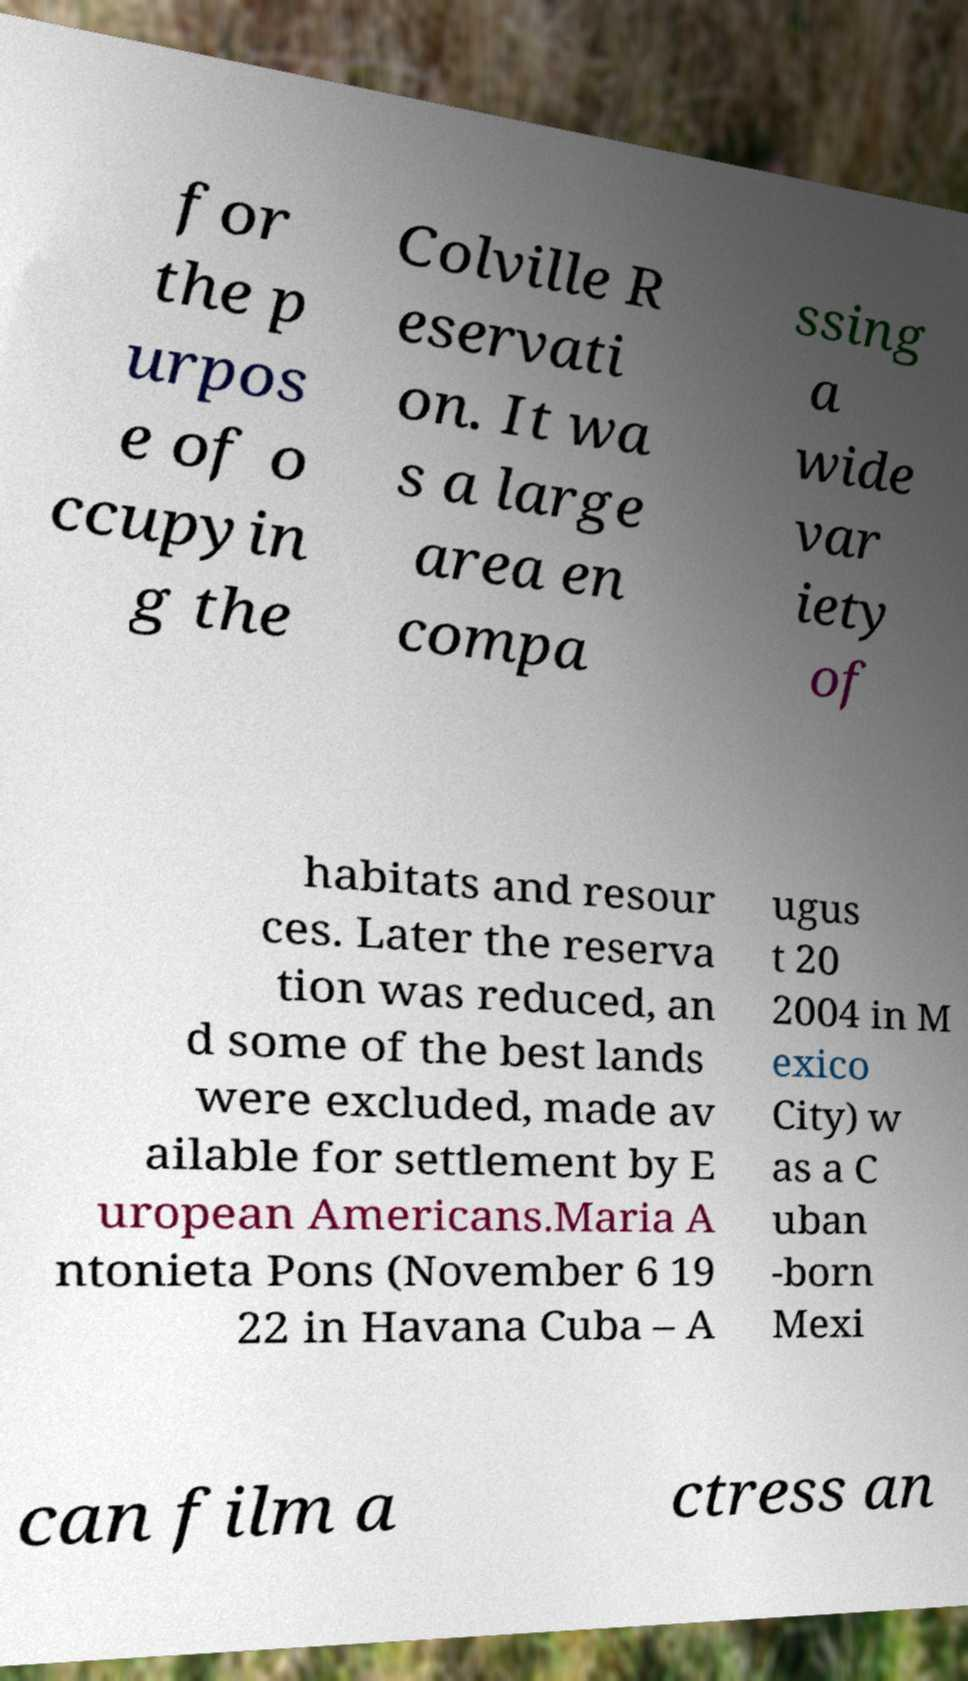Please identify and transcribe the text found in this image. for the p urpos e of o ccupyin g the Colville R eservati on. It wa s a large area en compa ssing a wide var iety of habitats and resour ces. Later the reserva tion was reduced, an d some of the best lands were excluded, made av ailable for settlement by E uropean Americans.Maria A ntonieta Pons (November 6 19 22 in Havana Cuba – A ugus t 20 2004 in M exico City) w as a C uban -born Mexi can film a ctress an 